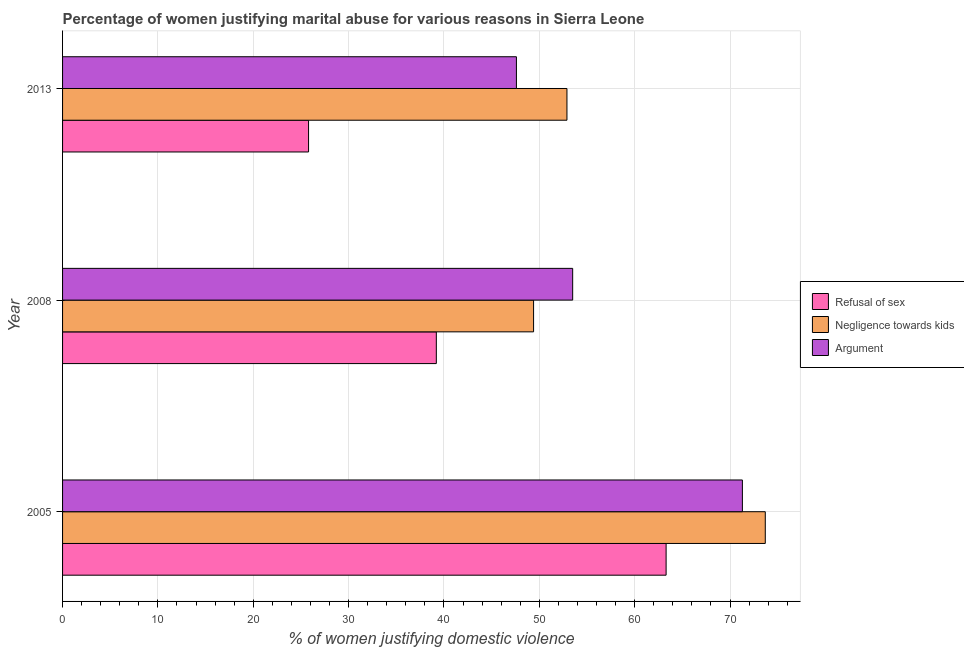How many different coloured bars are there?
Offer a terse response. 3. How many groups of bars are there?
Offer a very short reply. 3. Are the number of bars on each tick of the Y-axis equal?
Ensure brevity in your answer.  Yes. How many bars are there on the 2nd tick from the top?
Make the answer very short. 3. What is the label of the 1st group of bars from the top?
Provide a succinct answer. 2013. What is the percentage of women justifying domestic violence due to arguments in 2005?
Provide a succinct answer. 71.3. Across all years, what is the maximum percentage of women justifying domestic violence due to refusal of sex?
Offer a very short reply. 63.3. Across all years, what is the minimum percentage of women justifying domestic violence due to refusal of sex?
Your response must be concise. 25.8. In which year was the percentage of women justifying domestic violence due to negligence towards kids maximum?
Your answer should be very brief. 2005. What is the total percentage of women justifying domestic violence due to arguments in the graph?
Give a very brief answer. 172.4. What is the difference between the percentage of women justifying domestic violence due to arguments in 2008 and that in 2013?
Offer a terse response. 5.9. What is the difference between the percentage of women justifying domestic violence due to refusal of sex in 2005 and the percentage of women justifying domestic violence due to arguments in 2008?
Your answer should be compact. 9.8. What is the average percentage of women justifying domestic violence due to refusal of sex per year?
Ensure brevity in your answer.  42.77. In how many years, is the percentage of women justifying domestic violence due to arguments greater than 10 %?
Ensure brevity in your answer.  3. What is the ratio of the percentage of women justifying domestic violence due to refusal of sex in 2005 to that in 2008?
Your answer should be compact. 1.61. Is the percentage of women justifying domestic violence due to negligence towards kids in 2005 less than that in 2008?
Make the answer very short. No. Is the difference between the percentage of women justifying domestic violence due to arguments in 2005 and 2013 greater than the difference between the percentage of women justifying domestic violence due to negligence towards kids in 2005 and 2013?
Offer a terse response. Yes. What is the difference between the highest and the second highest percentage of women justifying domestic violence due to refusal of sex?
Provide a succinct answer. 24.1. What is the difference between the highest and the lowest percentage of women justifying domestic violence due to refusal of sex?
Your answer should be compact. 37.5. What does the 3rd bar from the top in 2013 represents?
Your response must be concise. Refusal of sex. What does the 1st bar from the bottom in 2008 represents?
Offer a very short reply. Refusal of sex. Is it the case that in every year, the sum of the percentage of women justifying domestic violence due to refusal of sex and percentage of women justifying domestic violence due to negligence towards kids is greater than the percentage of women justifying domestic violence due to arguments?
Ensure brevity in your answer.  Yes. Are all the bars in the graph horizontal?
Your response must be concise. Yes. How many years are there in the graph?
Keep it short and to the point. 3. Are the values on the major ticks of X-axis written in scientific E-notation?
Ensure brevity in your answer.  No. Does the graph contain any zero values?
Offer a terse response. No. Where does the legend appear in the graph?
Offer a terse response. Center right. What is the title of the graph?
Your answer should be very brief. Percentage of women justifying marital abuse for various reasons in Sierra Leone. Does "Wage workers" appear as one of the legend labels in the graph?
Your response must be concise. No. What is the label or title of the X-axis?
Give a very brief answer. % of women justifying domestic violence. What is the label or title of the Y-axis?
Keep it short and to the point. Year. What is the % of women justifying domestic violence in Refusal of sex in 2005?
Provide a succinct answer. 63.3. What is the % of women justifying domestic violence in Negligence towards kids in 2005?
Give a very brief answer. 73.7. What is the % of women justifying domestic violence of Argument in 2005?
Ensure brevity in your answer.  71.3. What is the % of women justifying domestic violence in Refusal of sex in 2008?
Give a very brief answer. 39.2. What is the % of women justifying domestic violence in Negligence towards kids in 2008?
Provide a short and direct response. 49.4. What is the % of women justifying domestic violence in Argument in 2008?
Provide a short and direct response. 53.5. What is the % of women justifying domestic violence of Refusal of sex in 2013?
Ensure brevity in your answer.  25.8. What is the % of women justifying domestic violence in Negligence towards kids in 2013?
Provide a short and direct response. 52.9. What is the % of women justifying domestic violence in Argument in 2013?
Keep it short and to the point. 47.6. Across all years, what is the maximum % of women justifying domestic violence of Refusal of sex?
Give a very brief answer. 63.3. Across all years, what is the maximum % of women justifying domestic violence in Negligence towards kids?
Your response must be concise. 73.7. Across all years, what is the maximum % of women justifying domestic violence in Argument?
Offer a very short reply. 71.3. Across all years, what is the minimum % of women justifying domestic violence of Refusal of sex?
Give a very brief answer. 25.8. Across all years, what is the minimum % of women justifying domestic violence of Negligence towards kids?
Keep it short and to the point. 49.4. Across all years, what is the minimum % of women justifying domestic violence of Argument?
Give a very brief answer. 47.6. What is the total % of women justifying domestic violence in Refusal of sex in the graph?
Make the answer very short. 128.3. What is the total % of women justifying domestic violence of Negligence towards kids in the graph?
Make the answer very short. 176. What is the total % of women justifying domestic violence in Argument in the graph?
Provide a succinct answer. 172.4. What is the difference between the % of women justifying domestic violence in Refusal of sex in 2005 and that in 2008?
Keep it short and to the point. 24.1. What is the difference between the % of women justifying domestic violence in Negligence towards kids in 2005 and that in 2008?
Offer a terse response. 24.3. What is the difference between the % of women justifying domestic violence of Argument in 2005 and that in 2008?
Make the answer very short. 17.8. What is the difference between the % of women justifying domestic violence in Refusal of sex in 2005 and that in 2013?
Your response must be concise. 37.5. What is the difference between the % of women justifying domestic violence in Negligence towards kids in 2005 and that in 2013?
Provide a short and direct response. 20.8. What is the difference between the % of women justifying domestic violence in Argument in 2005 and that in 2013?
Your answer should be very brief. 23.7. What is the difference between the % of women justifying domestic violence of Refusal of sex in 2008 and that in 2013?
Offer a terse response. 13.4. What is the difference between the % of women justifying domestic violence in Argument in 2008 and that in 2013?
Make the answer very short. 5.9. What is the difference between the % of women justifying domestic violence of Negligence towards kids in 2005 and the % of women justifying domestic violence of Argument in 2008?
Keep it short and to the point. 20.2. What is the difference between the % of women justifying domestic violence of Refusal of sex in 2005 and the % of women justifying domestic violence of Negligence towards kids in 2013?
Provide a short and direct response. 10.4. What is the difference between the % of women justifying domestic violence of Refusal of sex in 2005 and the % of women justifying domestic violence of Argument in 2013?
Provide a succinct answer. 15.7. What is the difference between the % of women justifying domestic violence of Negligence towards kids in 2005 and the % of women justifying domestic violence of Argument in 2013?
Provide a short and direct response. 26.1. What is the difference between the % of women justifying domestic violence in Refusal of sex in 2008 and the % of women justifying domestic violence in Negligence towards kids in 2013?
Your answer should be compact. -13.7. What is the difference between the % of women justifying domestic violence in Refusal of sex in 2008 and the % of women justifying domestic violence in Argument in 2013?
Provide a succinct answer. -8.4. What is the difference between the % of women justifying domestic violence of Negligence towards kids in 2008 and the % of women justifying domestic violence of Argument in 2013?
Provide a short and direct response. 1.8. What is the average % of women justifying domestic violence in Refusal of sex per year?
Keep it short and to the point. 42.77. What is the average % of women justifying domestic violence of Negligence towards kids per year?
Your answer should be very brief. 58.67. What is the average % of women justifying domestic violence in Argument per year?
Your answer should be compact. 57.47. In the year 2005, what is the difference between the % of women justifying domestic violence in Refusal of sex and % of women justifying domestic violence in Argument?
Make the answer very short. -8. In the year 2008, what is the difference between the % of women justifying domestic violence in Refusal of sex and % of women justifying domestic violence in Negligence towards kids?
Ensure brevity in your answer.  -10.2. In the year 2008, what is the difference between the % of women justifying domestic violence in Refusal of sex and % of women justifying domestic violence in Argument?
Keep it short and to the point. -14.3. In the year 2008, what is the difference between the % of women justifying domestic violence of Negligence towards kids and % of women justifying domestic violence of Argument?
Make the answer very short. -4.1. In the year 2013, what is the difference between the % of women justifying domestic violence in Refusal of sex and % of women justifying domestic violence in Negligence towards kids?
Make the answer very short. -27.1. In the year 2013, what is the difference between the % of women justifying domestic violence of Refusal of sex and % of women justifying domestic violence of Argument?
Offer a very short reply. -21.8. What is the ratio of the % of women justifying domestic violence of Refusal of sex in 2005 to that in 2008?
Your response must be concise. 1.61. What is the ratio of the % of women justifying domestic violence of Negligence towards kids in 2005 to that in 2008?
Your answer should be compact. 1.49. What is the ratio of the % of women justifying domestic violence of Argument in 2005 to that in 2008?
Your answer should be compact. 1.33. What is the ratio of the % of women justifying domestic violence in Refusal of sex in 2005 to that in 2013?
Provide a short and direct response. 2.45. What is the ratio of the % of women justifying domestic violence of Negligence towards kids in 2005 to that in 2013?
Your answer should be compact. 1.39. What is the ratio of the % of women justifying domestic violence of Argument in 2005 to that in 2013?
Provide a succinct answer. 1.5. What is the ratio of the % of women justifying domestic violence in Refusal of sex in 2008 to that in 2013?
Make the answer very short. 1.52. What is the ratio of the % of women justifying domestic violence of Negligence towards kids in 2008 to that in 2013?
Offer a very short reply. 0.93. What is the ratio of the % of women justifying domestic violence of Argument in 2008 to that in 2013?
Offer a very short reply. 1.12. What is the difference between the highest and the second highest % of women justifying domestic violence of Refusal of sex?
Your response must be concise. 24.1. What is the difference between the highest and the second highest % of women justifying domestic violence of Negligence towards kids?
Make the answer very short. 20.8. What is the difference between the highest and the second highest % of women justifying domestic violence in Argument?
Your answer should be very brief. 17.8. What is the difference between the highest and the lowest % of women justifying domestic violence in Refusal of sex?
Your answer should be compact. 37.5. What is the difference between the highest and the lowest % of women justifying domestic violence in Negligence towards kids?
Ensure brevity in your answer.  24.3. What is the difference between the highest and the lowest % of women justifying domestic violence of Argument?
Give a very brief answer. 23.7. 